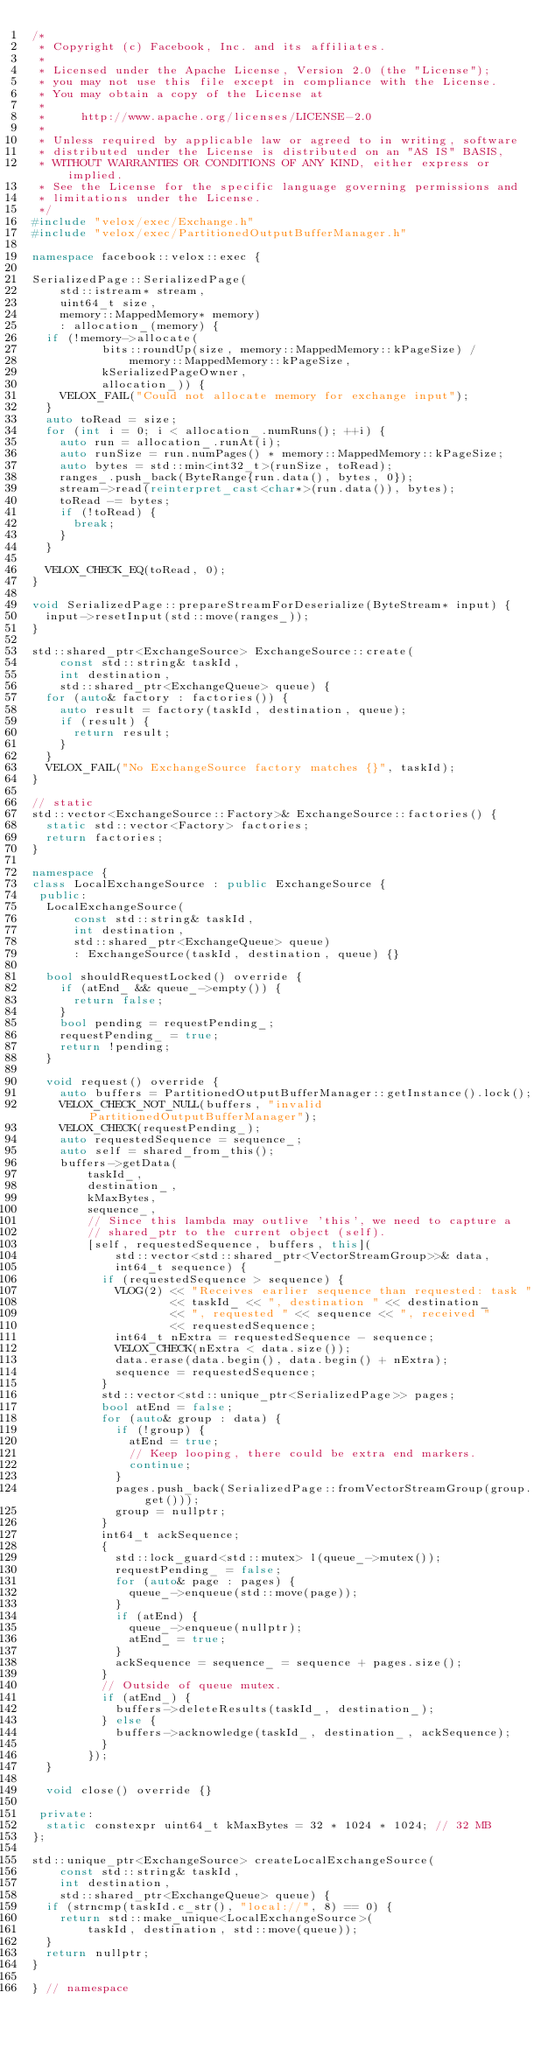<code> <loc_0><loc_0><loc_500><loc_500><_C++_>/*
 * Copyright (c) Facebook, Inc. and its affiliates.
 *
 * Licensed under the Apache License, Version 2.0 (the "License");
 * you may not use this file except in compliance with the License.
 * You may obtain a copy of the License at
 *
 *     http://www.apache.org/licenses/LICENSE-2.0
 *
 * Unless required by applicable law or agreed to in writing, software
 * distributed under the License is distributed on an "AS IS" BASIS,
 * WITHOUT WARRANTIES OR CONDITIONS OF ANY KIND, either express or implied.
 * See the License for the specific language governing permissions and
 * limitations under the License.
 */
#include "velox/exec/Exchange.h"
#include "velox/exec/PartitionedOutputBufferManager.h"

namespace facebook::velox::exec {

SerializedPage::SerializedPage(
    std::istream* stream,
    uint64_t size,
    memory::MappedMemory* memory)
    : allocation_(memory) {
  if (!memory->allocate(
          bits::roundUp(size, memory::MappedMemory::kPageSize) /
              memory::MappedMemory::kPageSize,
          kSerializedPageOwner,
          allocation_)) {
    VELOX_FAIL("Could not allocate memory for exchange input");
  }
  auto toRead = size;
  for (int i = 0; i < allocation_.numRuns(); ++i) {
    auto run = allocation_.runAt(i);
    auto runSize = run.numPages() * memory::MappedMemory::kPageSize;
    auto bytes = std::min<int32_t>(runSize, toRead);
    ranges_.push_back(ByteRange{run.data(), bytes, 0});
    stream->read(reinterpret_cast<char*>(run.data()), bytes);
    toRead -= bytes;
    if (!toRead) {
      break;
    }
  }

  VELOX_CHECK_EQ(toRead, 0);
}

void SerializedPage::prepareStreamForDeserialize(ByteStream* input) {
  input->resetInput(std::move(ranges_));
}

std::shared_ptr<ExchangeSource> ExchangeSource::create(
    const std::string& taskId,
    int destination,
    std::shared_ptr<ExchangeQueue> queue) {
  for (auto& factory : factories()) {
    auto result = factory(taskId, destination, queue);
    if (result) {
      return result;
    }
  }
  VELOX_FAIL("No ExchangeSource factory matches {}", taskId);
}

// static
std::vector<ExchangeSource::Factory>& ExchangeSource::factories() {
  static std::vector<Factory> factories;
  return factories;
}

namespace {
class LocalExchangeSource : public ExchangeSource {
 public:
  LocalExchangeSource(
      const std::string& taskId,
      int destination,
      std::shared_ptr<ExchangeQueue> queue)
      : ExchangeSource(taskId, destination, queue) {}

  bool shouldRequestLocked() override {
    if (atEnd_ && queue_->empty()) {
      return false;
    }
    bool pending = requestPending_;
    requestPending_ = true;
    return !pending;
  }

  void request() override {
    auto buffers = PartitionedOutputBufferManager::getInstance().lock();
    VELOX_CHECK_NOT_NULL(buffers, "invalid PartitionedOutputBufferManager");
    VELOX_CHECK(requestPending_);
    auto requestedSequence = sequence_;
    auto self = shared_from_this();
    buffers->getData(
        taskId_,
        destination_,
        kMaxBytes,
        sequence_,
        // Since this lambda may outlive 'this', we need to capture a
        // shared_ptr to the current object (self).
        [self, requestedSequence, buffers, this](
            std::vector<std::shared_ptr<VectorStreamGroup>>& data,
            int64_t sequence) {
          if (requestedSequence > sequence) {
            VLOG(2) << "Receives earlier sequence than requested: task "
                    << taskId_ << ", destination " << destination_
                    << ", requested " << sequence << ", received "
                    << requestedSequence;
            int64_t nExtra = requestedSequence - sequence;
            VELOX_CHECK(nExtra < data.size());
            data.erase(data.begin(), data.begin() + nExtra);
            sequence = requestedSequence;
          }
          std::vector<std::unique_ptr<SerializedPage>> pages;
          bool atEnd = false;
          for (auto& group : data) {
            if (!group) {
              atEnd = true;
              // Keep looping, there could be extra end markers.
              continue;
            }
            pages.push_back(SerializedPage::fromVectorStreamGroup(group.get()));
            group = nullptr;
          }
          int64_t ackSequence;
          {
            std::lock_guard<std::mutex> l(queue_->mutex());
            requestPending_ = false;
            for (auto& page : pages) {
              queue_->enqueue(std::move(page));
            }
            if (atEnd) {
              queue_->enqueue(nullptr);
              atEnd_ = true;
            }
            ackSequence = sequence_ = sequence + pages.size();
          }
          // Outside of queue mutex.
          if (atEnd_) {
            buffers->deleteResults(taskId_, destination_);
          } else {
            buffers->acknowledge(taskId_, destination_, ackSequence);
          }
        });
  }

  void close() override {}

 private:
  static constexpr uint64_t kMaxBytes = 32 * 1024 * 1024; // 32 MB
};

std::unique_ptr<ExchangeSource> createLocalExchangeSource(
    const std::string& taskId,
    int destination,
    std::shared_ptr<ExchangeQueue> queue) {
  if (strncmp(taskId.c_str(), "local://", 8) == 0) {
    return std::make_unique<LocalExchangeSource>(
        taskId, destination, std::move(queue));
  }
  return nullptr;
}

} // namespace
</code> 